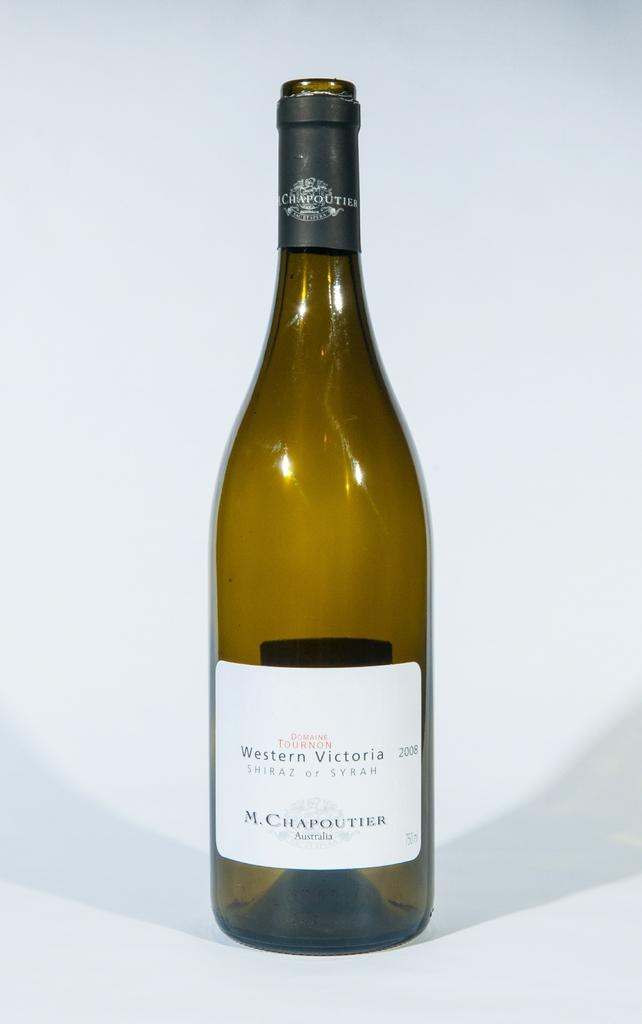<image>
Summarize the visual content of the image. A bottle of White Shiraz from Western Victoria. 